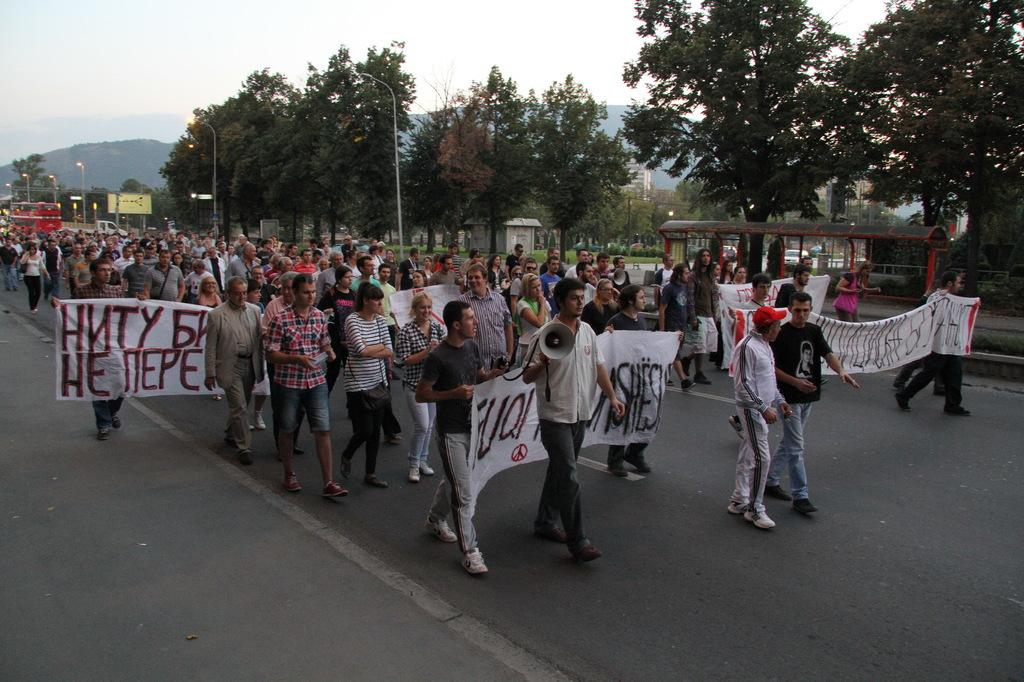What are the people in the image doing? The people in the image are standing on the road. What are the people holding in their hands? The people are holding cloth banners in their hands. Can you describe any other objects being held by the people in the image? A man is holding a megaphone in his hand. What type of furniture can be seen in the image? There is no furniture present in the image. How many beads are visible on the man holding the megaphone? There are no beads visible on the man holding the megaphone in the image. 